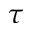Convert formula to latex. <formula><loc_0><loc_0><loc_500><loc_500>\tau</formula> 